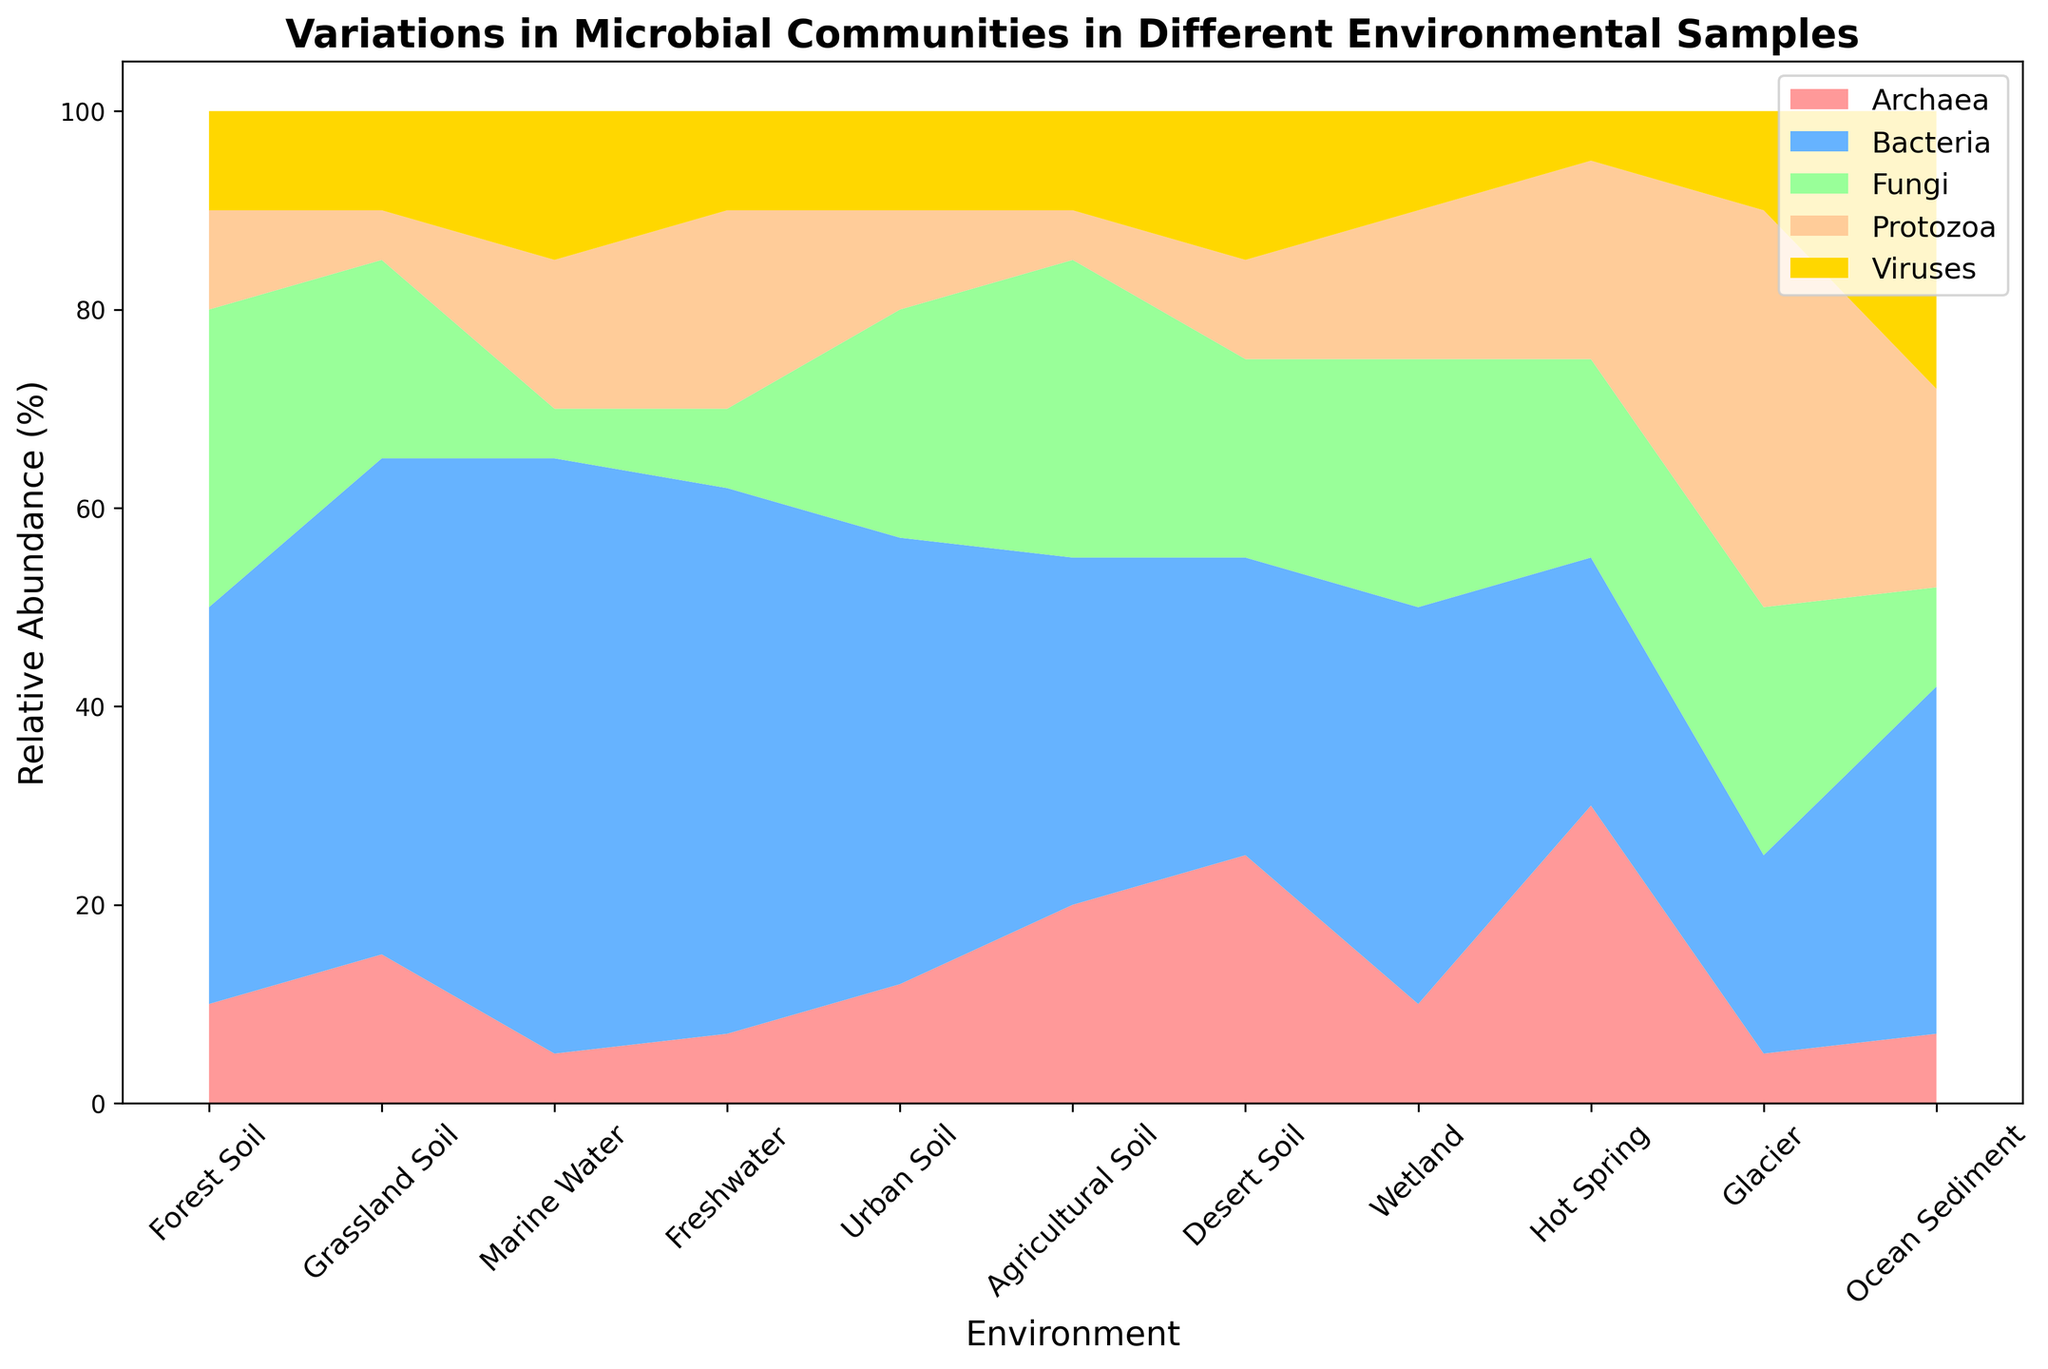What percentage of microbial communities in Urban Soil are of type Fungi and Protozoa combined? From the figure, the percentage of Fungi in Urban Soil is 23% and Protozoa is 10%. Adding these percentages together gives 23% + 10%.
Answer: 33% Which environment has the highest relative abundance of Archaea? Visual inspection of the area chart shows that the "Hot Spring" section has the largest height for Archaea.
Answer: Hot Spring Is the relative abundance of Viruses in Marine Water greater than in Glacier? The area for Viruses in Marine Water is visually 15%, while in Glacier it is 10%. Since 15% is greater than 10%, the relative abundance of Viruses in Marine Water is greater.
Answer: Yes Among Forest Soil, Grassland Soil, and Desert Soil, which has the largest combined relative abundance of Bacteria and Fungi? Sum the percentages of Bacteria and Fungi for each environment: 
Forest Soil: 40% + 30% = 70% 
Grassland Soil: 50% + 20% = 70% 
Desert Soil: 30% + 20% = 50%
Forest Soil and Grassland Soil each have the largest combined percentage of 70%.
Answer: Forest Soil and Grassland Soil What is the average relative abundance of Bacteria across all environments? Sum the relative abundances of Bacteria in each environment and divide by the number of environments:
(40% + 50% + 60% + 55% + 45% + 35% + 30% + 40% + 25% + 20% + 35%) / 11 = 435% / 11
Answer: 39.55% Which two environments have the closest relative abundance of Protozoa? Comparing the heights of the Protozoa areas across all environments visually, Forest Soil and Urban Soil both have 10%, Grassland Soil and Agricultural Soil both have 5%.
Answer: Forest Soil and Urban Soil In which environment is the relative abundance of Fungi greater than in Freshwater? Visual inspection shows that the environments with relative abundance of Fungi greater than Freshwater (8%) are Forest Soil (30%), Urban Soil (23%), Glacier (25%), and Hot Spring (20%).
Answer: Forest Soil, Urban Soil, Glacier, Hot Spring Is the sum of the relative abundances of all microbial communities in Wetland 100%? To verify, sum the relative abundances in Wetland: 
10% (archaea) + 40% (bacteria) + 25% (fungi) + 15% (protozoa) + 10% (viruses) = 100%
Answer: Yes What is the difference in the relative abundance of Protozoa between Ocean Sediment and Grassland Soil? Subtract the relative abundance of Protozoa in Grassland Soil from that in Ocean Sediment: 20% - 5% = 15%
Answer: 15% Which microbial community has the smallest relative abundance in Hot Spring? Visual inspection shows that in Hot Spring, the smallest section corresponds to Viruses, with 5%.
Answer: Viruses 